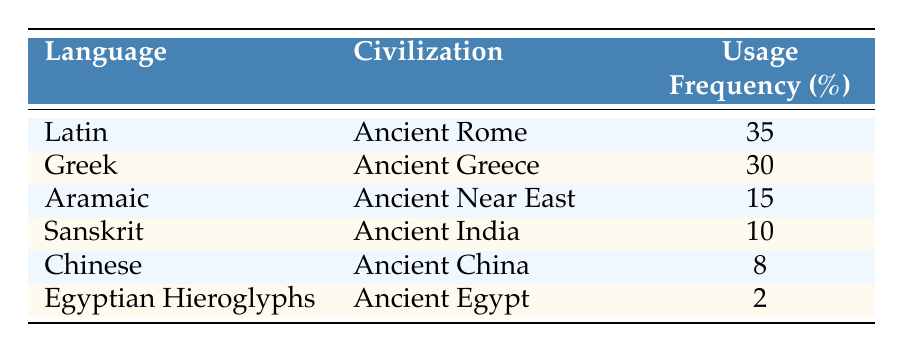What's the language with the highest usage frequency? By looking at the "Usage Frequency" column, I can see that Latin has the highest value of 35.
Answer: Latin Which civilization corresponds to the language Sanskrit? The table lists Sanskrit under the civilization "Ancient India."
Answer: Ancient India What is the combined usage frequency of Greek and Aramaic? To find the combined usage frequency, I add the usage frequencies of Greek (30) and Aramaic (15): 30 + 15 = 45.
Answer: 45 Is Egyptian Hieroglyphs the least used language in this table? Yes, Egyptian Hieroglyphs has a usage frequency of 2, which is lower than all other languages listed.
Answer: Yes What percentage of the total usage frequency does Chinese represent? First, sum up all usage frequencies: 35 + 30 + 15 + 10 + 8 + 2 = 100. Then, calculate the percentage for Chinese: (8/100) * 100 = 8%.
Answer: 8% Which language has a usage frequency greater than 25? The languages with a frequency greater than 25 are Latin (35) and Greek (30) from the table.
Answer: Latin and Greek What is the difference in usage frequency between Latin and Chinese? The difference is calculated by subtracting Chinese's usage frequency (8) from Latin's (35): 35 - 8 = 27.
Answer: 27 Are there more languages with a usage frequency over 10 than those below 10? Yes, there are four languages over 10 (Latin, Greek, Aramaic, and Sanskrit) and two below (Chinese and Egyptian Hieroglyphs).
Answer: Yes What is the average usage frequency of languages in this table? I sum the usage frequencies: 35 + 30 + 15 + 10 + 8 + 2 = 100, then divide by the number of languages (6): 100/6 = approximately 16.67.
Answer: 16.67 